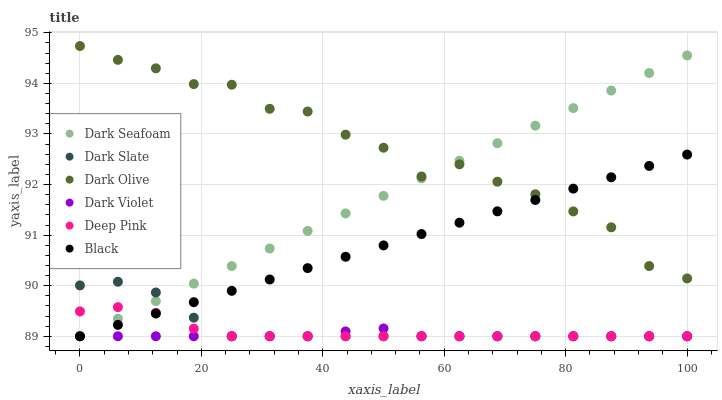Does Dark Violet have the minimum area under the curve?
Answer yes or no. Yes. Does Dark Olive have the maximum area under the curve?
Answer yes or no. Yes. Does Dark Olive have the minimum area under the curve?
Answer yes or no. No. Does Dark Violet have the maximum area under the curve?
Answer yes or no. No. Is Dark Seafoam the smoothest?
Answer yes or no. Yes. Is Dark Olive the roughest?
Answer yes or no. Yes. Is Dark Violet the smoothest?
Answer yes or no. No. Is Dark Violet the roughest?
Answer yes or no. No. Does Deep Pink have the lowest value?
Answer yes or no. Yes. Does Dark Olive have the lowest value?
Answer yes or no. No. Does Dark Olive have the highest value?
Answer yes or no. Yes. Does Dark Violet have the highest value?
Answer yes or no. No. Is Dark Slate less than Dark Olive?
Answer yes or no. Yes. Is Dark Olive greater than Dark Slate?
Answer yes or no. Yes. Does Dark Seafoam intersect Deep Pink?
Answer yes or no. Yes. Is Dark Seafoam less than Deep Pink?
Answer yes or no. No. Is Dark Seafoam greater than Deep Pink?
Answer yes or no. No. Does Dark Slate intersect Dark Olive?
Answer yes or no. No. 